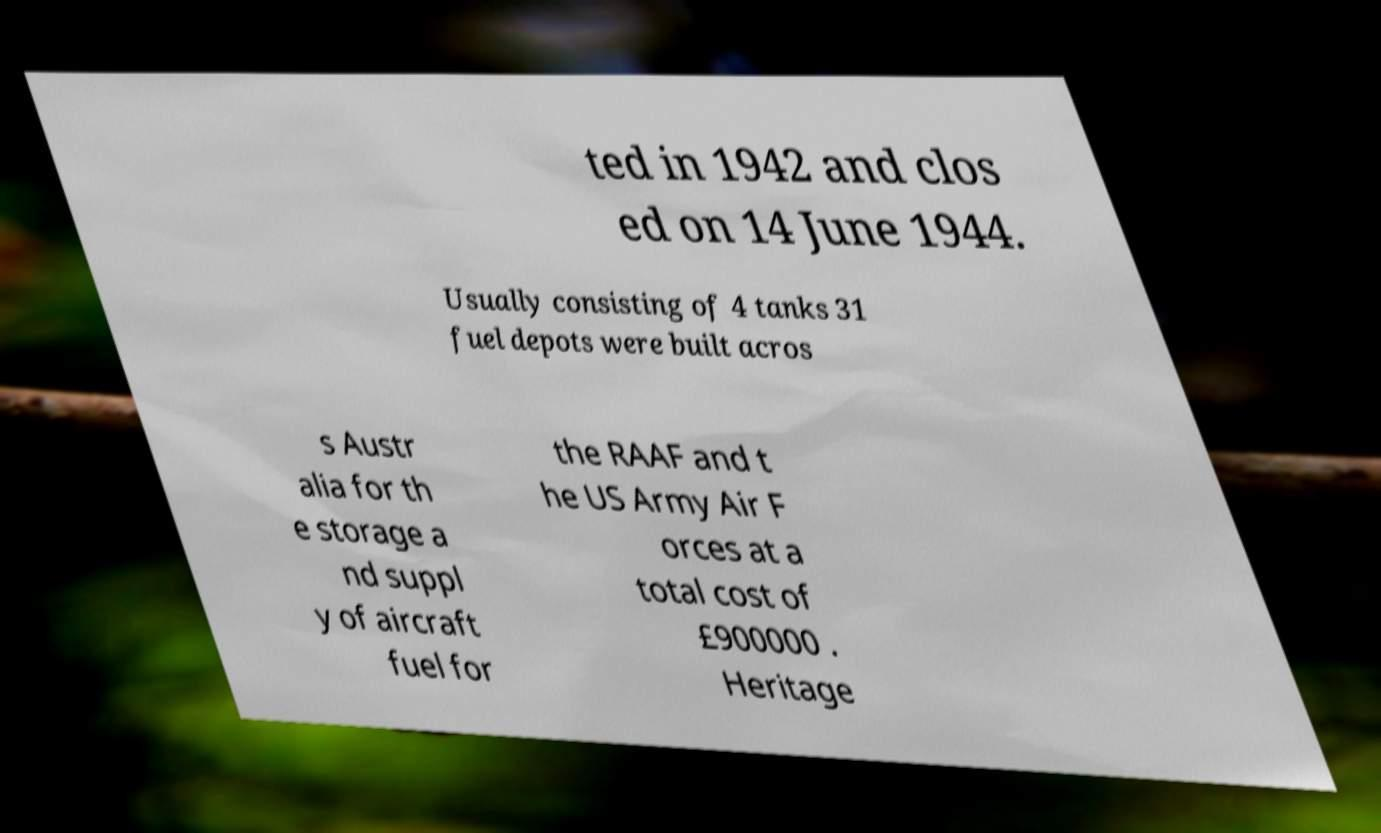There's text embedded in this image that I need extracted. Can you transcribe it verbatim? ted in 1942 and clos ed on 14 June 1944. Usually consisting of 4 tanks 31 fuel depots were built acros s Austr alia for th e storage a nd suppl y of aircraft fuel for the RAAF and t he US Army Air F orces at a total cost of £900000 . Heritage 